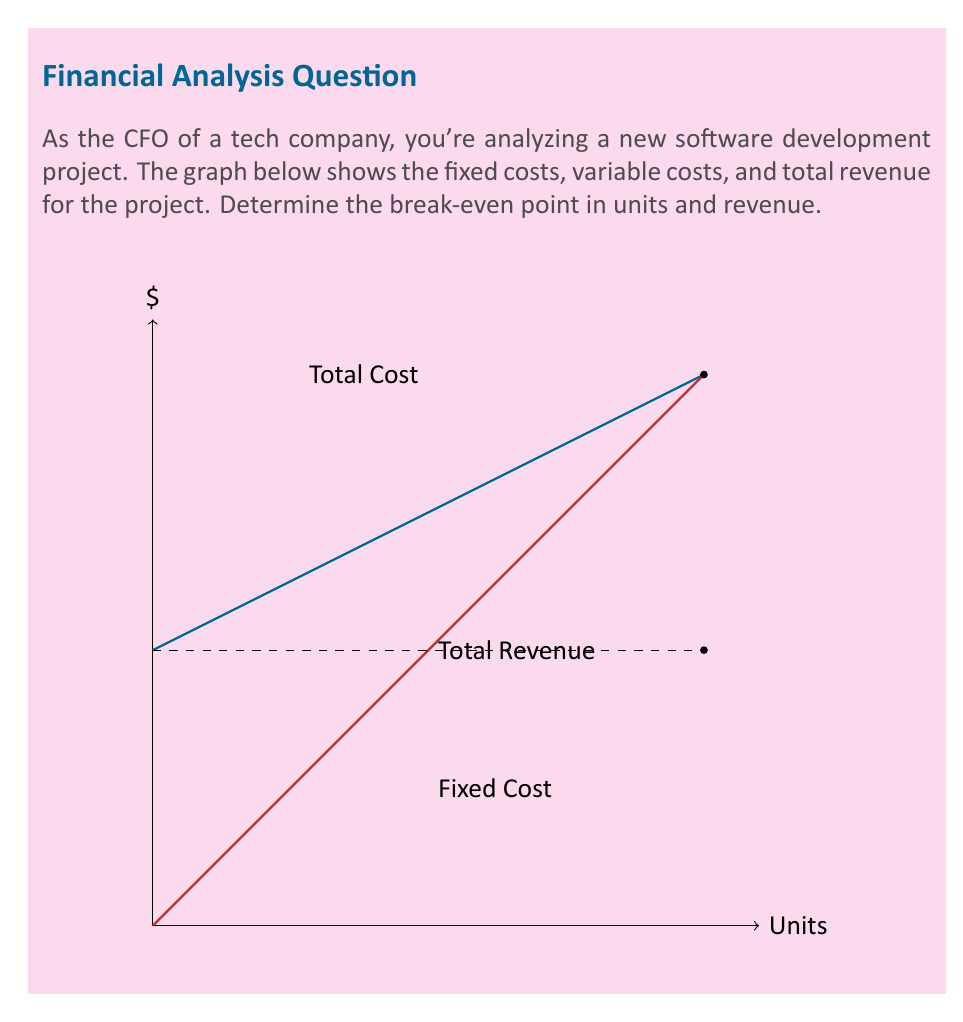Give your solution to this math problem. To find the break-even point, we need to determine where total revenue equals total cost. Let's approach this step-by-step:

1) From the graph, we can deduce:
   Fixed Cost (FC) = $5000
   Variable Cost per unit (VC) = slope of Total Cost line = $50
   Price per unit (P) = slope of Total Revenue line = $100

2) At break-even point:
   Total Revenue = Total Cost
   $$ Px = FC + VCx $$
   Where x is the number of units.

3) Substituting the values:
   $$ 100x = 5000 + 50x $$

4) Solving for x:
   $$ 100x - 50x = 5000 $$
   $$ 50x = 5000 $$
   $$ x = 100 \text{ units} $$

5) To find the break-even revenue:
   Revenue = Price * Units
   $$ R = 100 * 100 = $10,000 $$

Therefore, the break-even point is 100 units or $10,000 in revenue.
Answer: 100 units; $10,000 